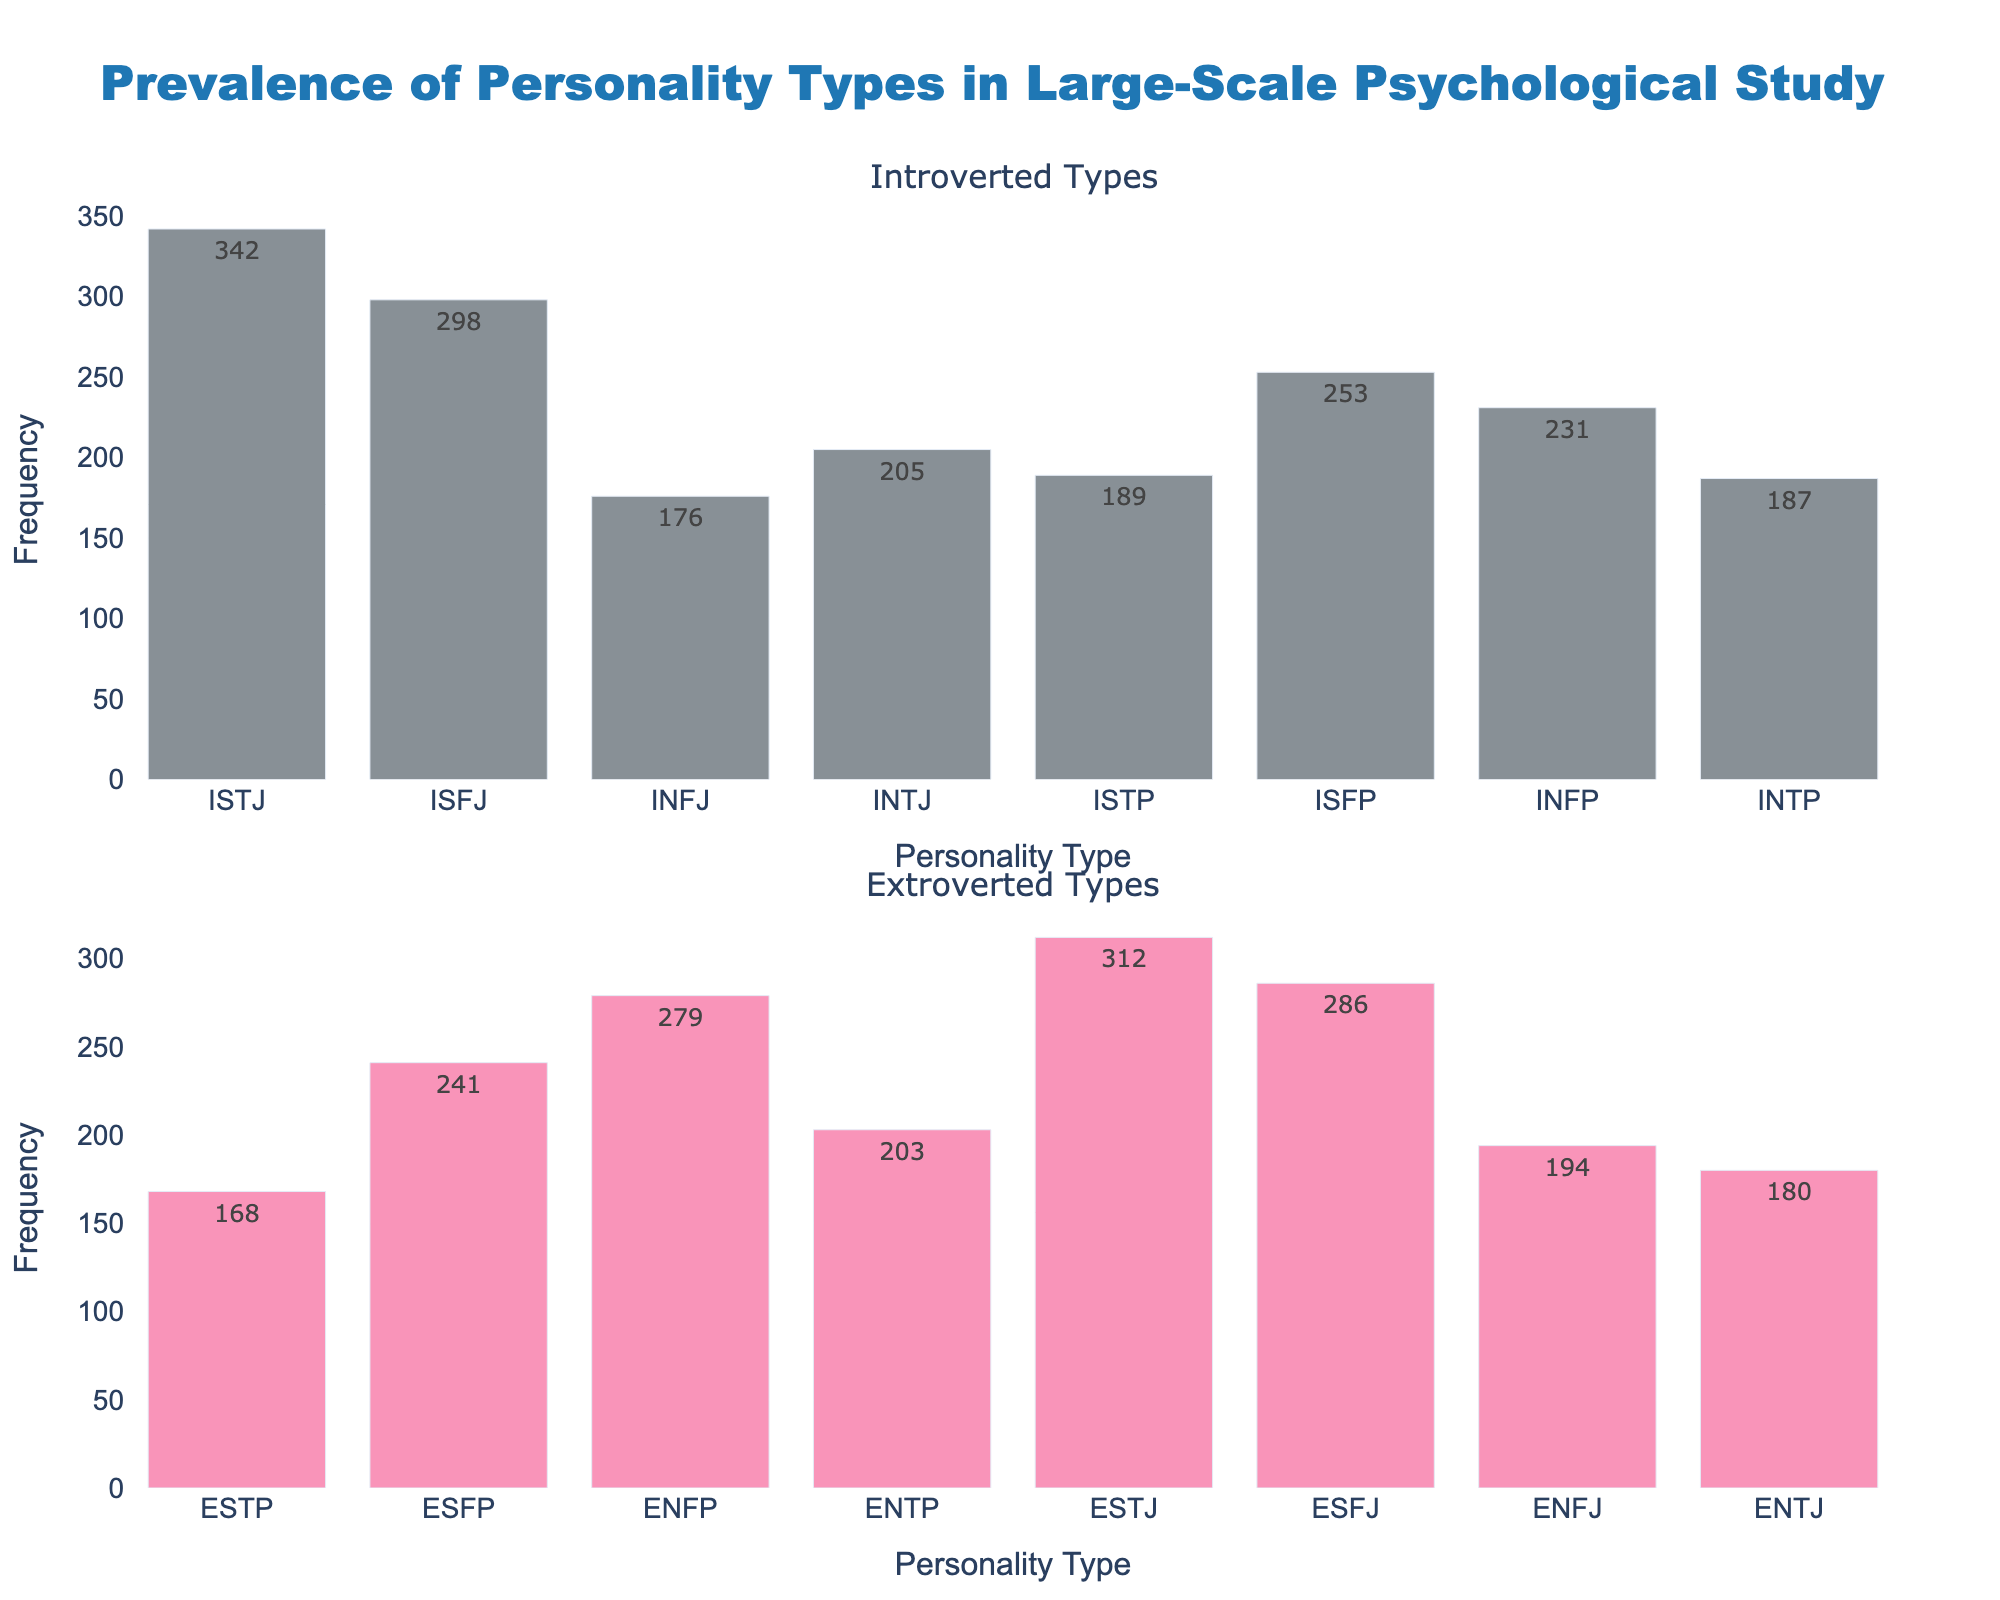What's the title of the figure? The title of the figure is prominently displayed at the top of the plot. By examining the top part of the figure, we can see the text used for the title.
Answer: Prevalence of Personality Types in Large-Scale Psychological Study How many different personality types are presented in the figure? There are two subplots, each showing bars representing different personality types. The figure shows 8 bars in each subplot, thus there are 16 personality types in total.
Answer: 16 Which personality type has the highest frequency among introverted types? By looking at the heights of the bars in the first subplot (Introverted Types), the tallest bar represents the personality type ISTJ. The frequency is visible as 342.
Answer: ISTJ What's the sum of frequencies for all Extroverted types? To find the sum, add up the frequencies for all extroverted types: 168 (ESTP) + 241 (ESFP) + 279 (ENFP) + 203 (ENTP) + 312 (ESTJ) + 286 (ESFJ) + 194 (ENFJ) + 180 (ENTJ). The total is 1863.
Answer: 1863 Which Extroverted personality type has the lowest frequency? By examining the second subplot (Extroverted Types), the shortest bar represents the personality type ESTP. The frequency is visible as 168.
Answer: ESTP How does the frequency of ENFP compare to ISFJ? Compare the height of the bars for ENFP in the second subplot to ISFJ in the first subplot. ENFP has a frequency of 279, and ISFJ has 298. 279 is less than 298.
Answer: ENFP is less frequent What is the average frequency of Introverted personality types? To find the average, sum up the frequencies of all introverted types: 342 (ISTJ) + 298 (ISFJ) + 176 (INFJ) + 205 (INTJ) + 189 (ISTP) + 253 (ISFP) + 231 (INFP) + 187 (INTP). The total is 1881. Divide by the number of introverted types (8) to get an average: 1881 / 8 = 235.1
Answer: 235.1 Which personality type is the third most common among Extroverted types? Order the frequencies of Extroverted types in descending order: 312 (ESTJ), 286 (ESFJ), 279 (ENFP), etc. ENFP is the third highest frequency.
Answer: ENFP What is the difference in frequency between the most and least common Introverted personality types? The most common Introverted personality type is ISTJ with a frequency of 342, and the least common is INFJ with a frequency of 176. The difference is 342 - 176 = 166.
Answer: 166 